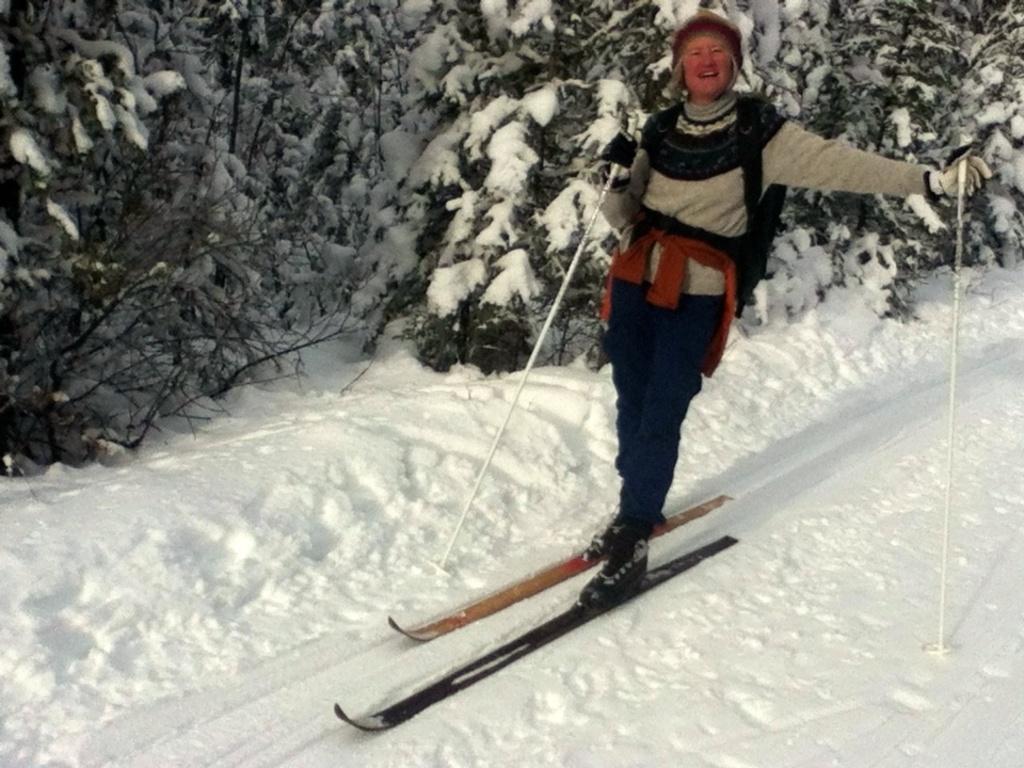How would you summarize this image in a sentence or two? There is a person in gray color t-shirt, holding sticks with both hands and standing on the snow boards. Which are on the snow surface. In the background, there are trees. On which, there is snow. 